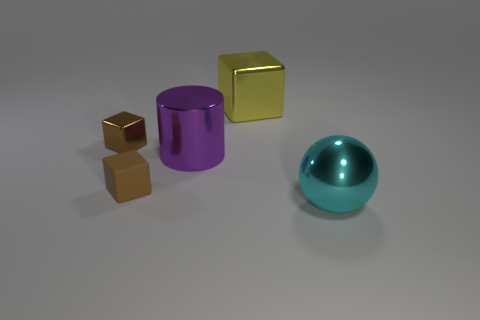Subtract all metallic blocks. How many blocks are left? 1 Add 3 blue blocks. How many objects exist? 8 Subtract all cubes. How many objects are left? 2 Subtract 1 brown blocks. How many objects are left? 4 Subtract all cyan rubber objects. Subtract all large cylinders. How many objects are left? 4 Add 5 large cyan spheres. How many large cyan spheres are left? 6 Add 3 large purple objects. How many large purple objects exist? 4 